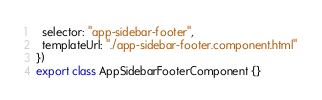<code> <loc_0><loc_0><loc_500><loc_500><_TypeScript_>  selector: "app-sidebar-footer",
  templateUrl: "./app-sidebar-footer.component.html"
})
export class AppSidebarFooterComponent {}
</code> 